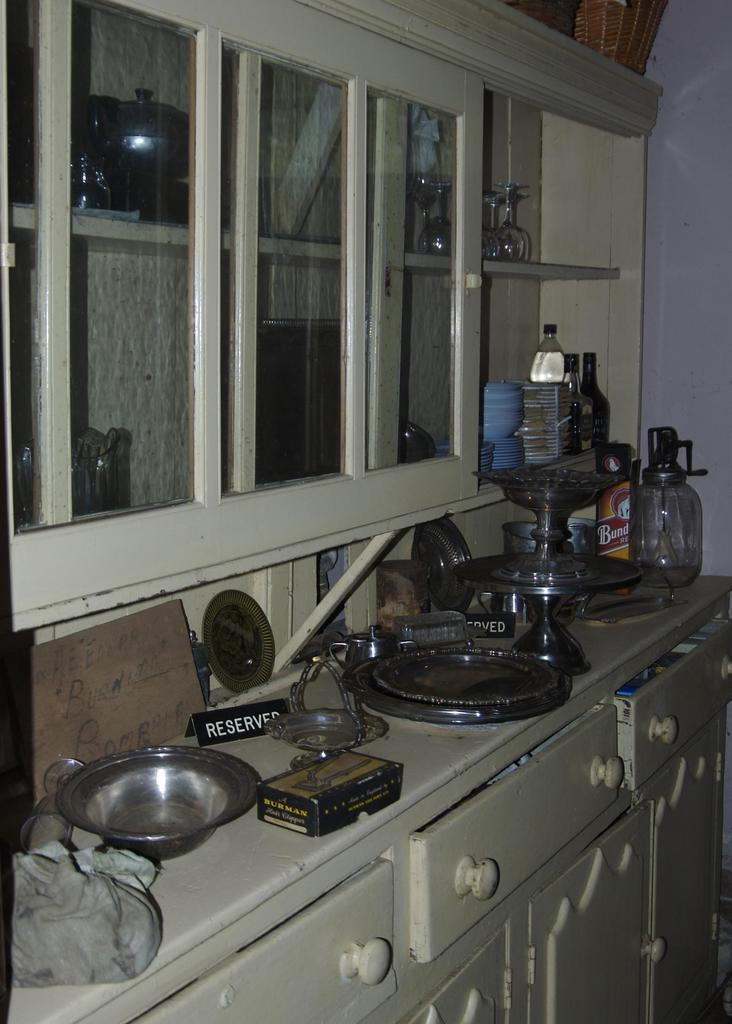<image>
Render a clear and concise summary of the photo. a bathroom with a sign that says reserved on it 